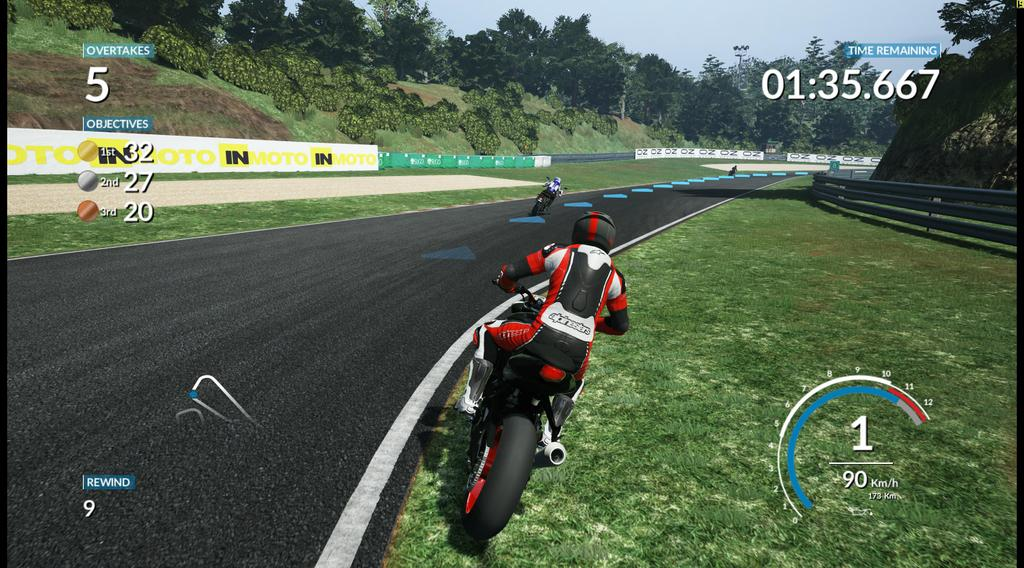What type of game is the image related to? The image is related to an animation game. What vehicles are present in the image? There are bikes in the image. How many persons can be seen in the image? There are persons in the image. What type of terrain is visible in the image? There is grass in the image. What type of barrier is present in the image? There is a fence in the image. What type of advertisement is present in the image? There are hoardings in the image. What type of vegetation is visible in the image? There are trees in the image. Can you see any dust particles in the image? There is no mention of dust particles in the image, so it cannot be determined if they are present. Are there any airplanes visible in the image? There is no mention of airplanes in the image, so it cannot be determined if they are present. 